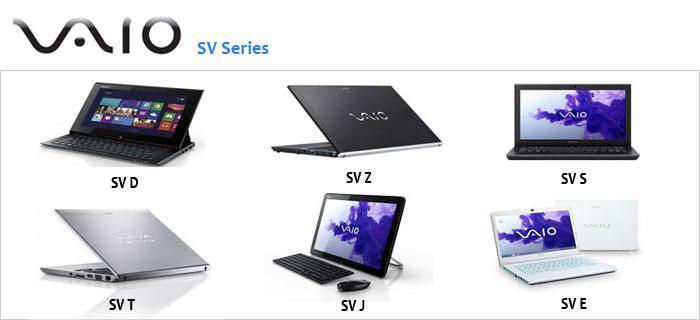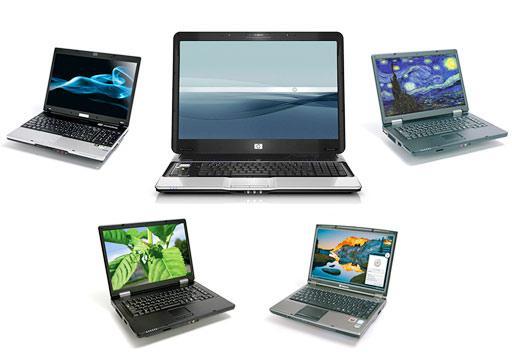The first image is the image on the left, the second image is the image on the right. Assess this claim about the two images: "There is an image of a bird on the screen of one of the computers in the image on the left.". Correct or not? Answer yes or no. No. 